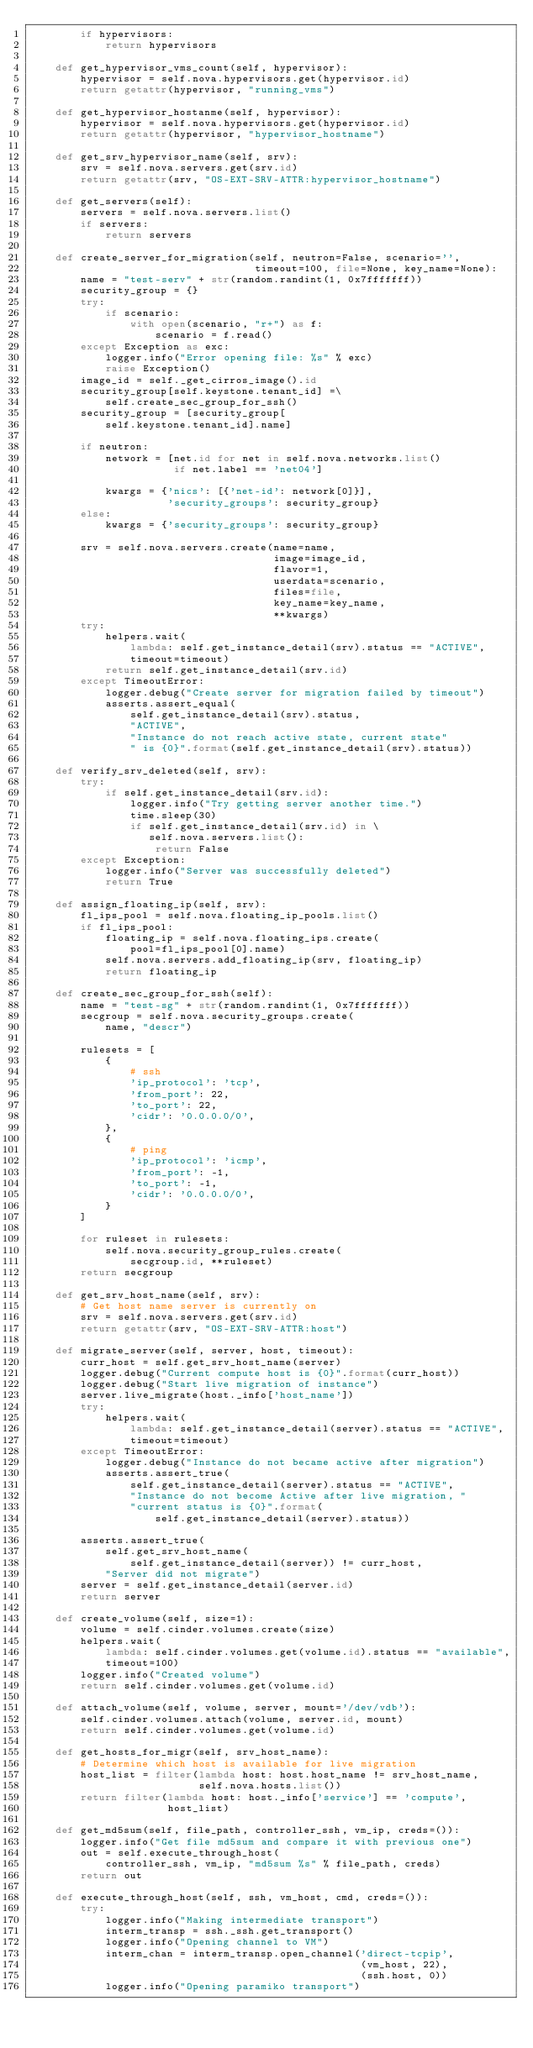Convert code to text. <code><loc_0><loc_0><loc_500><loc_500><_Python_>        if hypervisors:
            return hypervisors

    def get_hypervisor_vms_count(self, hypervisor):
        hypervisor = self.nova.hypervisors.get(hypervisor.id)
        return getattr(hypervisor, "running_vms")

    def get_hypervisor_hostanme(self, hypervisor):
        hypervisor = self.nova.hypervisors.get(hypervisor.id)
        return getattr(hypervisor, "hypervisor_hostname")

    def get_srv_hypervisor_name(self, srv):
        srv = self.nova.servers.get(srv.id)
        return getattr(srv, "OS-EXT-SRV-ATTR:hypervisor_hostname")

    def get_servers(self):
        servers = self.nova.servers.list()
        if servers:
            return servers

    def create_server_for_migration(self, neutron=False, scenario='',
                                    timeout=100, file=None, key_name=None):
        name = "test-serv" + str(random.randint(1, 0x7fffffff))
        security_group = {}
        try:
            if scenario:
                with open(scenario, "r+") as f:
                    scenario = f.read()
        except Exception as exc:
            logger.info("Error opening file: %s" % exc)
            raise Exception()
        image_id = self._get_cirros_image().id
        security_group[self.keystone.tenant_id] =\
            self.create_sec_group_for_ssh()
        security_group = [security_group[
            self.keystone.tenant_id].name]

        if neutron:
            network = [net.id for net in self.nova.networks.list()
                       if net.label == 'net04']

            kwargs = {'nics': [{'net-id': network[0]}],
                      'security_groups': security_group}
        else:
            kwargs = {'security_groups': security_group}

        srv = self.nova.servers.create(name=name,
                                       image=image_id,
                                       flavor=1,
                                       userdata=scenario,
                                       files=file,
                                       key_name=key_name,
                                       **kwargs)
        try:
            helpers.wait(
                lambda: self.get_instance_detail(srv).status == "ACTIVE",
                timeout=timeout)
            return self.get_instance_detail(srv.id)
        except TimeoutError:
            logger.debug("Create server for migration failed by timeout")
            asserts.assert_equal(
                self.get_instance_detail(srv).status,
                "ACTIVE",
                "Instance do not reach active state, current state"
                " is {0}".format(self.get_instance_detail(srv).status))

    def verify_srv_deleted(self, srv):
        try:
            if self.get_instance_detail(srv.id):
                logger.info("Try getting server another time.")
                time.sleep(30)
                if self.get_instance_detail(srv.id) in \
                   self.nova.servers.list():
                    return False
        except Exception:
            logger.info("Server was successfully deleted")
            return True

    def assign_floating_ip(self, srv):
        fl_ips_pool = self.nova.floating_ip_pools.list()
        if fl_ips_pool:
            floating_ip = self.nova.floating_ips.create(
                pool=fl_ips_pool[0].name)
            self.nova.servers.add_floating_ip(srv, floating_ip)
            return floating_ip

    def create_sec_group_for_ssh(self):
        name = "test-sg" + str(random.randint(1, 0x7fffffff))
        secgroup = self.nova.security_groups.create(
            name, "descr")

        rulesets = [
            {
                # ssh
                'ip_protocol': 'tcp',
                'from_port': 22,
                'to_port': 22,
                'cidr': '0.0.0.0/0',
            },
            {
                # ping
                'ip_protocol': 'icmp',
                'from_port': -1,
                'to_port': -1,
                'cidr': '0.0.0.0/0',
            }
        ]

        for ruleset in rulesets:
            self.nova.security_group_rules.create(
                secgroup.id, **ruleset)
        return secgroup

    def get_srv_host_name(self, srv):
        # Get host name server is currently on
        srv = self.nova.servers.get(srv.id)
        return getattr(srv, "OS-EXT-SRV-ATTR:host")

    def migrate_server(self, server, host, timeout):
        curr_host = self.get_srv_host_name(server)
        logger.debug("Current compute host is {0}".format(curr_host))
        logger.debug("Start live migration of instance")
        server.live_migrate(host._info['host_name'])
        try:
            helpers.wait(
                lambda: self.get_instance_detail(server).status == "ACTIVE",
                timeout=timeout)
        except TimeoutError:
            logger.debug("Instance do not became active after migration")
            asserts.assert_true(
                self.get_instance_detail(server).status == "ACTIVE",
                "Instance do not become Active after live migration, "
                "current status is {0}".format(
                    self.get_instance_detail(server).status))

        asserts.assert_true(
            self.get_srv_host_name(
                self.get_instance_detail(server)) != curr_host,
            "Server did not migrate")
        server = self.get_instance_detail(server.id)
        return server

    def create_volume(self, size=1):
        volume = self.cinder.volumes.create(size)
        helpers.wait(
            lambda: self.cinder.volumes.get(volume.id).status == "available",
            timeout=100)
        logger.info("Created volume")
        return self.cinder.volumes.get(volume.id)

    def attach_volume(self, volume, server, mount='/dev/vdb'):
        self.cinder.volumes.attach(volume, server.id, mount)
        return self.cinder.volumes.get(volume.id)

    def get_hosts_for_migr(self, srv_host_name):
        # Determine which host is available for live migration
        host_list = filter(lambda host: host.host_name != srv_host_name,
                           self.nova.hosts.list())
        return filter(lambda host: host._info['service'] == 'compute',
                      host_list)

    def get_md5sum(self, file_path, controller_ssh, vm_ip, creds=()):
        logger.info("Get file md5sum and compare it with previous one")
        out = self.execute_through_host(
            controller_ssh, vm_ip, "md5sum %s" % file_path, creds)
        return out

    def execute_through_host(self, ssh, vm_host, cmd, creds=()):
        try:
            logger.info("Making intermediate transport")
            interm_transp = ssh._ssh.get_transport()
            logger.info("Opening channel to VM")
            interm_chan = interm_transp.open_channel('direct-tcpip',
                                                     (vm_host, 22),
                                                     (ssh.host, 0))
            logger.info("Opening paramiko transport")</code> 